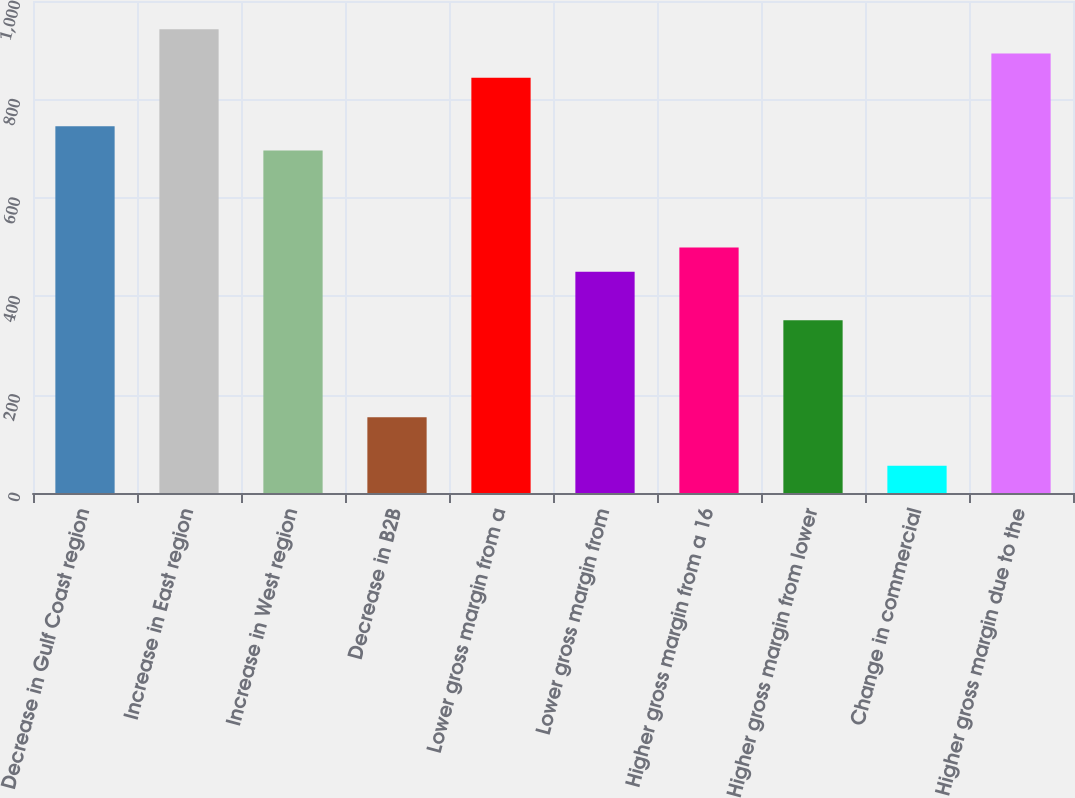<chart> <loc_0><loc_0><loc_500><loc_500><bar_chart><fcel>Decrease in Gulf Coast region<fcel>Increase in East region<fcel>Increase in West region<fcel>Decrease in B2B<fcel>Lower gross margin from a<fcel>Lower gross margin from<fcel>Higher gross margin from a 16<fcel>Higher gross margin from lower<fcel>Change in commercial<fcel>Higher gross margin due to the<nl><fcel>745.5<fcel>942.7<fcel>696.2<fcel>153.9<fcel>844.1<fcel>449.7<fcel>499<fcel>351.1<fcel>55.3<fcel>893.4<nl></chart> 